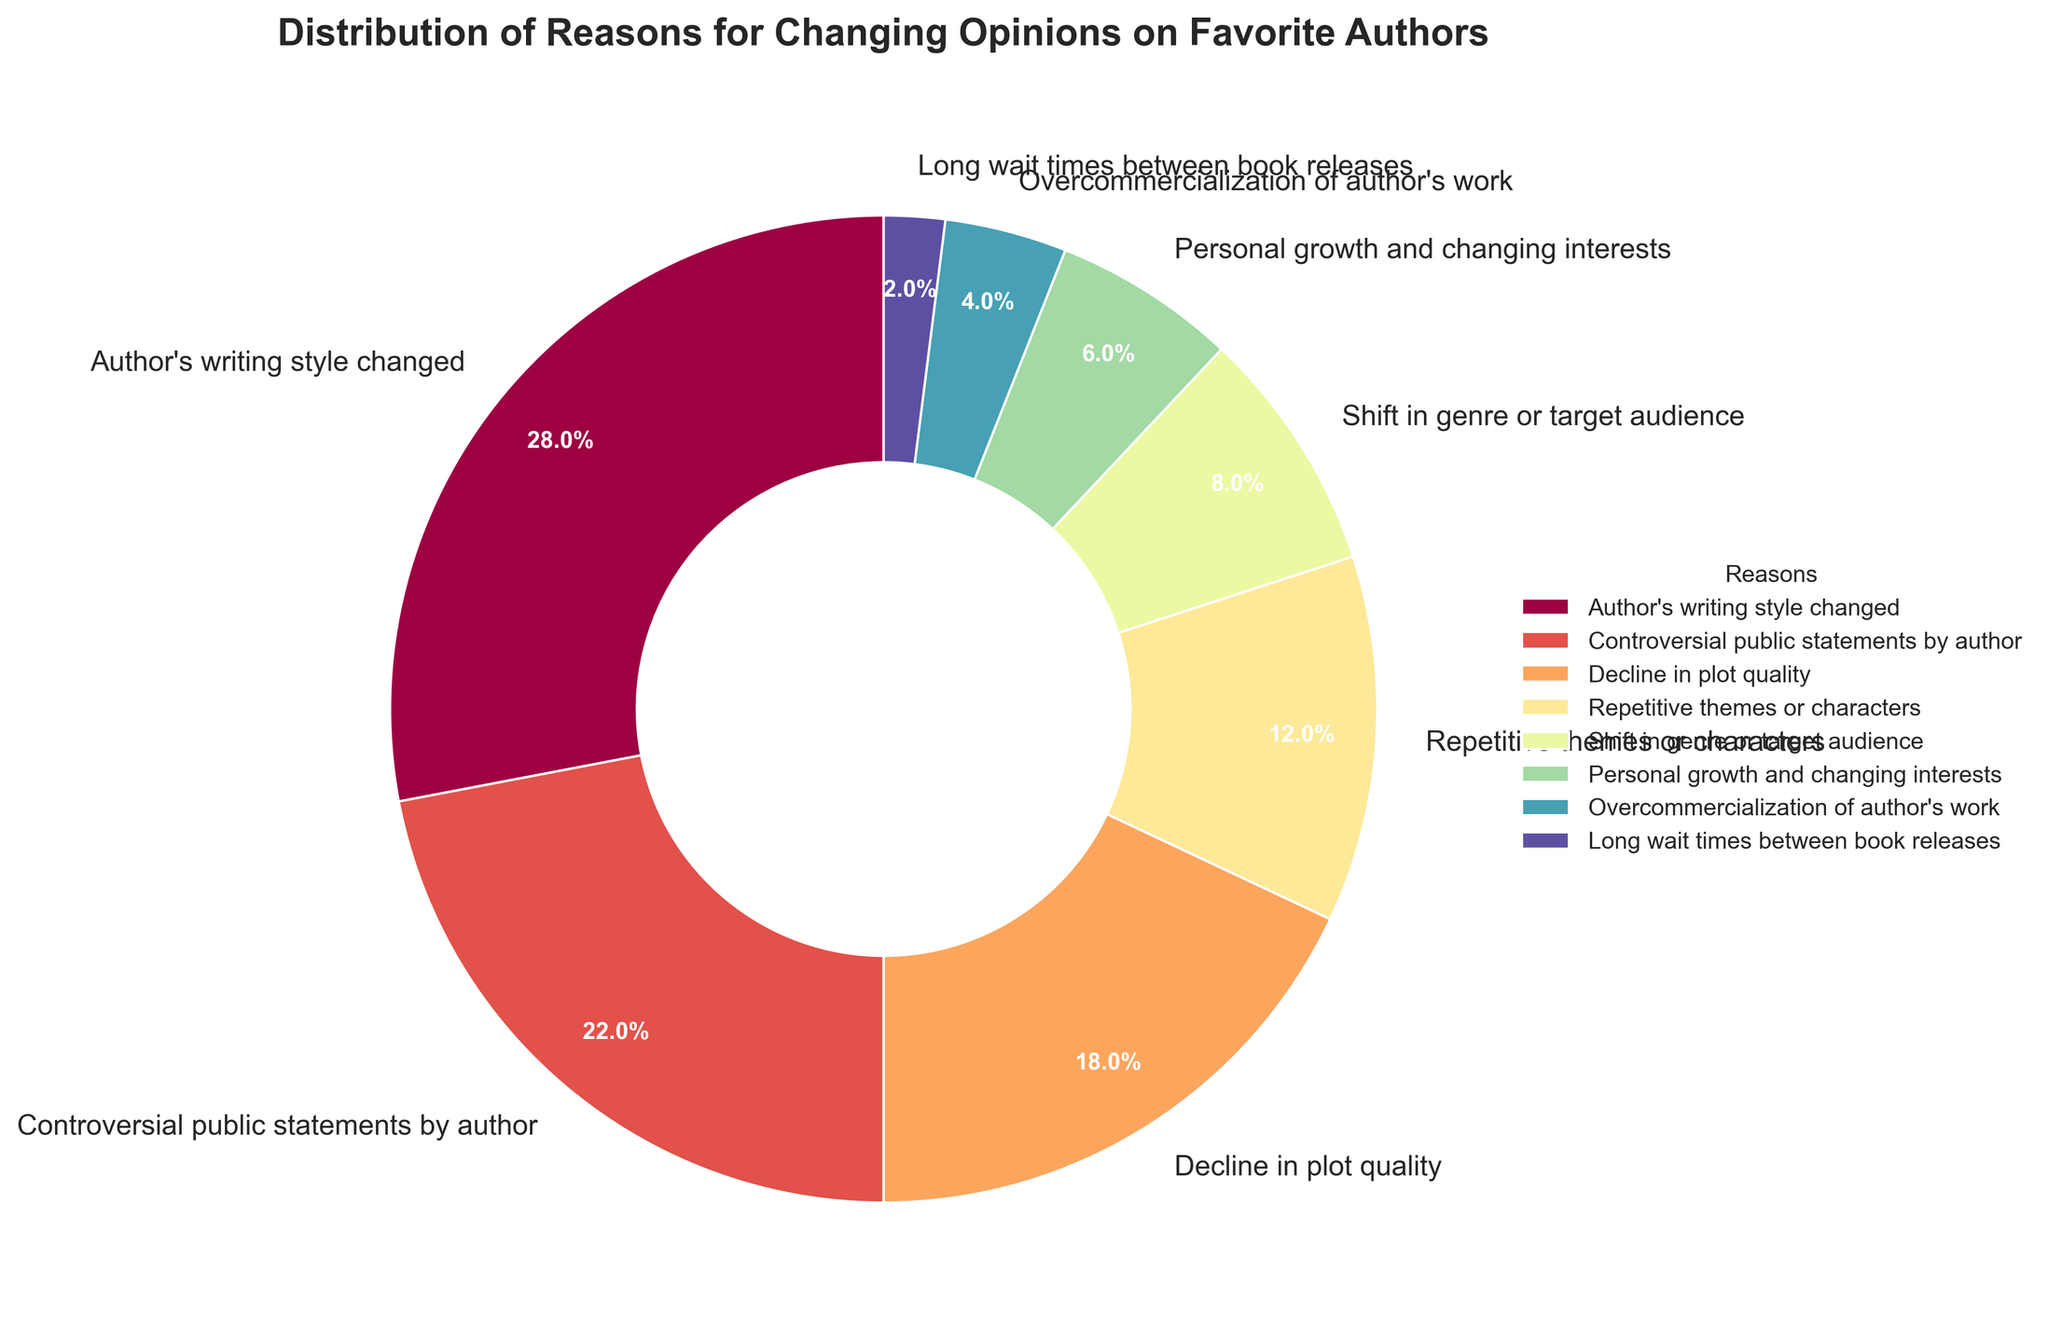What is the most common reason for changing opinions on favorite authors? Refer to the figure and identify the largest wedge by area. It corresponds to "Author's writing style changed" with 28%.
Answer: Author's writing style changed Which reason accounts for more of the percentage, "Decline in plot quality" or "Controversial public statements by author"? Compare the percentages for these two reasons from the chart. "Controversial public statements by author" is 22%, and "Decline in plot quality" is 18%.
Answer: Controversial public statements by author What is the combined percentage of reasons related to the content of the books ("Author's writing style changed", "Decline in plot quality", "Repetitive themes or characters")? Add the percentages: 28% (Author's writing style changed) + 18% (Decline in plot quality) + 12% (Repetitive themes or characters) = 58%.
Answer: 58% Is the percentage of "Long wait times between book releases" greater than "Overcommercialization of author's work"? Compare the two percentages. "Long wait times between book releases" is 2%, while "Overcommercialization of author's work" is 4%.
Answer: No Which segment is the second largest, and what percentage does it represent? Identify the second-largest wedge. It corresponds to "Controversial public statements by author" with 22%.
Answer: Controversial public statements by author, 22% What is the difference in percentage between "Author's writing style changed" and "Repetitive themes or characters"? Subtract the smaller percentage from the larger one: 28% (Author's writing style changed) - 12% (Repetitive themes or characters) = 16%.
Answer: 16% Which reason has the smallest representation in the chart, and what is its percentage? Find the smallest wedge in the pie chart. "Long wait times between book releases" with 2% is the smallest.
Answer: Long wait times between book releases, 2% Do "Shift in genre or target audience" and "Personal growth and changing interests" together account for more than or less than 20%? Add the percentages: 8% (Shift in genre or target audience) + 6% (Personal growth and changing interests) = 14%.
Answer: Less than Which reasons combined make up exactly half of the distribution percentage? Sum the percentages of pairs or groups until you find a sum of 50%. The sum of "Author's writing style changed" (28%) and "Controversial public statements by author" (22%) is 50%.
Answer: Author's writing style changed and Controversial public statements by author Which three reasons combined have the lowest percentages together? Add the percentages of the smallest three values: 2% (Long wait times between book releases) + 4% (Overcommercialization of author's work) + 6% (Personal growth and changing interests) = 12%.
Answer: Long wait times between book releases, Overcommercialization of author's work, Personal growth and changing interests 